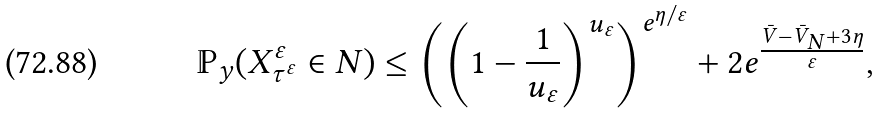Convert formula to latex. <formula><loc_0><loc_0><loc_500><loc_500>\mathbb { P } _ { y } ( X ^ { \varepsilon } _ { \tau ^ { \varepsilon } } \in N ) \leq \left ( \left ( 1 - \frac { 1 } { u _ { \varepsilon } } \right ) ^ { u _ { \varepsilon } } \right ) ^ { e ^ { \eta / \varepsilon } } + 2 e ^ { \frac { \bar { V } - \bar { V } _ { N } + 3 \eta } { \varepsilon } } ,</formula> 